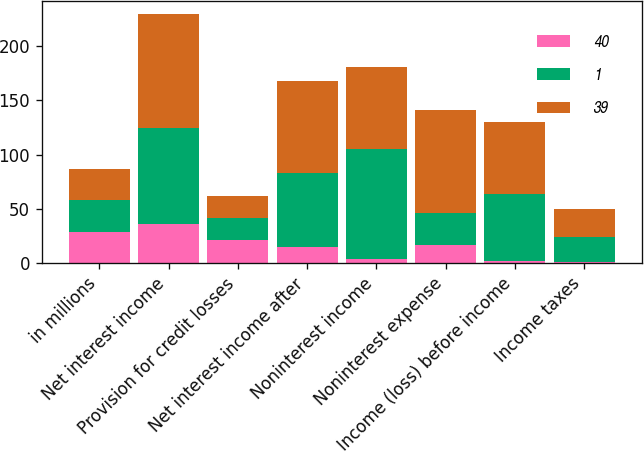<chart> <loc_0><loc_0><loc_500><loc_500><stacked_bar_chart><ecel><fcel>in millions<fcel>Net interest income<fcel>Provision for credit losses<fcel>Net interest income after<fcel>Noninterest income<fcel>Noninterest expense<fcel>Income (loss) before income<fcel>Income taxes<nl><fcel>40<fcel>29<fcel>36<fcel>21<fcel>15<fcel>4<fcel>17<fcel>2<fcel>1<nl><fcel>1<fcel>29<fcel>89<fcel>21<fcel>68<fcel>101<fcel>29<fcel>62<fcel>23<nl><fcel>39<fcel>29<fcel>105<fcel>20<fcel>85<fcel>76<fcel>95<fcel>66<fcel>26<nl></chart> 